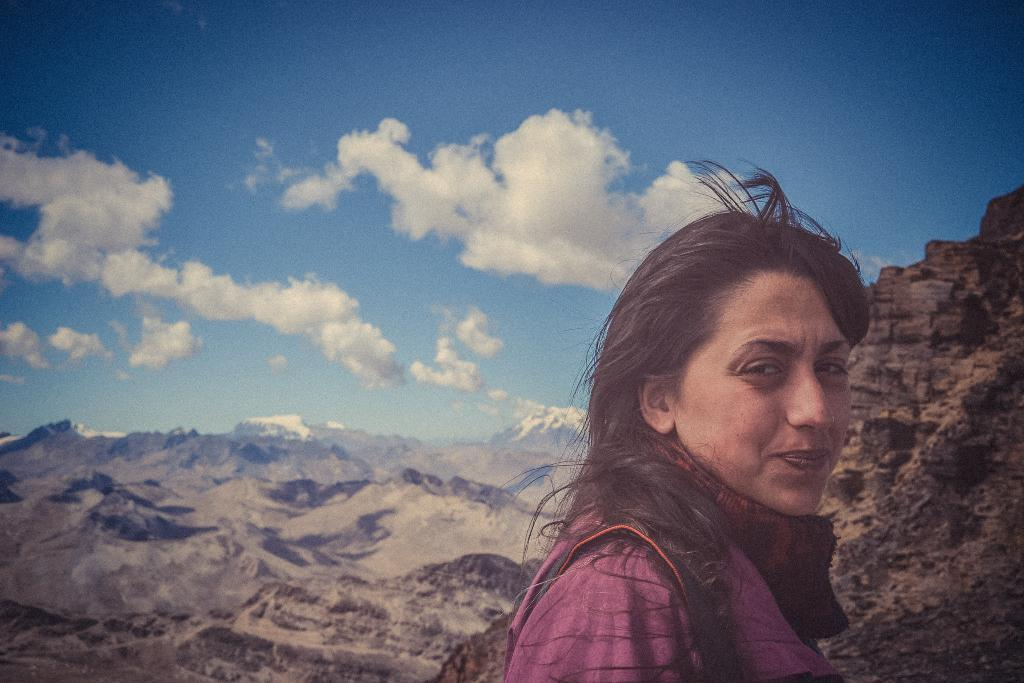Who is present in the image? There is a lady in the image. What is the lady holding in the image? The lady is holding a bag. What can be seen in the background of the image? There are dew mountains and clouds visible in the background of the image. What type of engine can be seen in the image? There is no engine present in the image. How does the fog affect the visibility in the image? There is no fog present in the image; it only shows clouds in the sky. 